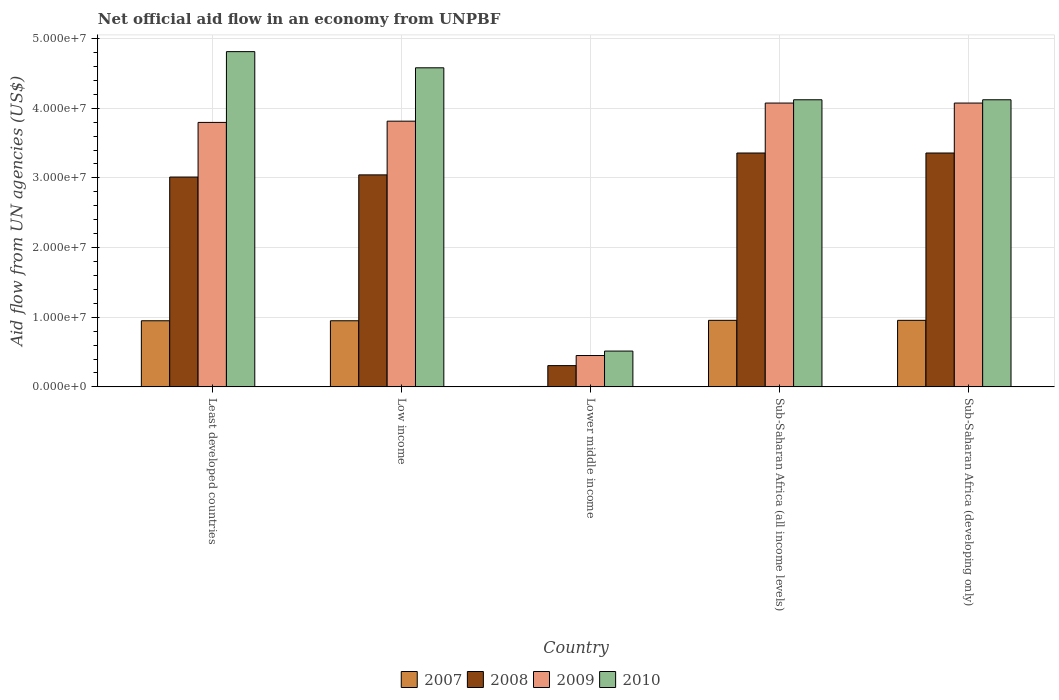How many different coloured bars are there?
Offer a very short reply. 4. How many groups of bars are there?
Your answer should be compact. 5. Are the number of bars per tick equal to the number of legend labels?
Keep it short and to the point. Yes. Are the number of bars on each tick of the X-axis equal?
Give a very brief answer. Yes. How many bars are there on the 5th tick from the left?
Provide a short and direct response. 4. How many bars are there on the 5th tick from the right?
Give a very brief answer. 4. What is the label of the 3rd group of bars from the left?
Provide a short and direct response. Lower middle income. In how many cases, is the number of bars for a given country not equal to the number of legend labels?
Your response must be concise. 0. What is the net official aid flow in 2007 in Sub-Saharan Africa (all income levels)?
Keep it short and to the point. 9.55e+06. Across all countries, what is the maximum net official aid flow in 2010?
Make the answer very short. 4.81e+07. Across all countries, what is the minimum net official aid flow in 2010?
Your response must be concise. 5.14e+06. In which country was the net official aid flow in 2009 maximum?
Keep it short and to the point. Sub-Saharan Africa (all income levels). In which country was the net official aid flow in 2009 minimum?
Your response must be concise. Lower middle income. What is the total net official aid flow in 2009 in the graph?
Your answer should be compact. 1.62e+08. What is the difference between the net official aid flow in 2009 in Low income and that in Sub-Saharan Africa (all income levels)?
Your answer should be compact. -2.60e+06. What is the difference between the net official aid flow in 2010 in Low income and the net official aid flow in 2009 in Sub-Saharan Africa (all income levels)?
Your answer should be very brief. 5.06e+06. What is the average net official aid flow in 2010 per country?
Keep it short and to the point. 3.63e+07. What is the difference between the net official aid flow of/in 2009 and net official aid flow of/in 2008 in Lower middle income?
Make the answer very short. 1.45e+06. In how many countries, is the net official aid flow in 2010 greater than 38000000 US$?
Ensure brevity in your answer.  4. What is the ratio of the net official aid flow in 2010 in Lower middle income to that in Sub-Saharan Africa (all income levels)?
Provide a succinct answer. 0.12. What is the difference between the highest and the second highest net official aid flow in 2010?
Offer a terse response. 2.32e+06. What is the difference between the highest and the lowest net official aid flow in 2008?
Provide a short and direct response. 3.05e+07. In how many countries, is the net official aid flow in 2007 greater than the average net official aid flow in 2007 taken over all countries?
Give a very brief answer. 4. Is the sum of the net official aid flow in 2010 in Least developed countries and Lower middle income greater than the maximum net official aid flow in 2008 across all countries?
Offer a very short reply. Yes. Is it the case that in every country, the sum of the net official aid flow in 2008 and net official aid flow in 2009 is greater than the sum of net official aid flow in 2007 and net official aid flow in 2010?
Make the answer very short. No. What does the 2nd bar from the left in Lower middle income represents?
Offer a very short reply. 2008. How many bars are there?
Your answer should be compact. 20. Are all the bars in the graph horizontal?
Provide a succinct answer. No. How many countries are there in the graph?
Your answer should be very brief. 5. What is the difference between two consecutive major ticks on the Y-axis?
Your answer should be compact. 1.00e+07. Does the graph contain grids?
Provide a short and direct response. Yes. How many legend labels are there?
Give a very brief answer. 4. How are the legend labels stacked?
Ensure brevity in your answer.  Horizontal. What is the title of the graph?
Provide a short and direct response. Net official aid flow in an economy from UNPBF. What is the label or title of the Y-axis?
Give a very brief answer. Aid flow from UN agencies (US$). What is the Aid flow from UN agencies (US$) of 2007 in Least developed countries?
Keep it short and to the point. 9.49e+06. What is the Aid flow from UN agencies (US$) of 2008 in Least developed countries?
Your response must be concise. 3.01e+07. What is the Aid flow from UN agencies (US$) in 2009 in Least developed countries?
Make the answer very short. 3.80e+07. What is the Aid flow from UN agencies (US$) of 2010 in Least developed countries?
Provide a succinct answer. 4.81e+07. What is the Aid flow from UN agencies (US$) of 2007 in Low income?
Make the answer very short. 9.49e+06. What is the Aid flow from UN agencies (US$) in 2008 in Low income?
Provide a short and direct response. 3.04e+07. What is the Aid flow from UN agencies (US$) of 2009 in Low income?
Your answer should be compact. 3.81e+07. What is the Aid flow from UN agencies (US$) in 2010 in Low income?
Provide a succinct answer. 4.58e+07. What is the Aid flow from UN agencies (US$) in 2008 in Lower middle income?
Your response must be concise. 3.05e+06. What is the Aid flow from UN agencies (US$) in 2009 in Lower middle income?
Provide a succinct answer. 4.50e+06. What is the Aid flow from UN agencies (US$) of 2010 in Lower middle income?
Give a very brief answer. 5.14e+06. What is the Aid flow from UN agencies (US$) of 2007 in Sub-Saharan Africa (all income levels)?
Your response must be concise. 9.55e+06. What is the Aid flow from UN agencies (US$) of 2008 in Sub-Saharan Africa (all income levels)?
Give a very brief answer. 3.36e+07. What is the Aid flow from UN agencies (US$) of 2009 in Sub-Saharan Africa (all income levels)?
Offer a very short reply. 4.07e+07. What is the Aid flow from UN agencies (US$) in 2010 in Sub-Saharan Africa (all income levels)?
Provide a succinct answer. 4.12e+07. What is the Aid flow from UN agencies (US$) in 2007 in Sub-Saharan Africa (developing only)?
Your answer should be compact. 9.55e+06. What is the Aid flow from UN agencies (US$) of 2008 in Sub-Saharan Africa (developing only)?
Give a very brief answer. 3.36e+07. What is the Aid flow from UN agencies (US$) of 2009 in Sub-Saharan Africa (developing only)?
Keep it short and to the point. 4.07e+07. What is the Aid flow from UN agencies (US$) in 2010 in Sub-Saharan Africa (developing only)?
Your response must be concise. 4.12e+07. Across all countries, what is the maximum Aid flow from UN agencies (US$) of 2007?
Provide a succinct answer. 9.55e+06. Across all countries, what is the maximum Aid flow from UN agencies (US$) of 2008?
Offer a very short reply. 3.36e+07. Across all countries, what is the maximum Aid flow from UN agencies (US$) in 2009?
Your answer should be compact. 4.07e+07. Across all countries, what is the maximum Aid flow from UN agencies (US$) in 2010?
Offer a terse response. 4.81e+07. Across all countries, what is the minimum Aid flow from UN agencies (US$) in 2007?
Your answer should be compact. 6.00e+04. Across all countries, what is the minimum Aid flow from UN agencies (US$) of 2008?
Offer a terse response. 3.05e+06. Across all countries, what is the minimum Aid flow from UN agencies (US$) in 2009?
Your answer should be very brief. 4.50e+06. Across all countries, what is the minimum Aid flow from UN agencies (US$) in 2010?
Provide a succinct answer. 5.14e+06. What is the total Aid flow from UN agencies (US$) in 2007 in the graph?
Offer a terse response. 3.81e+07. What is the total Aid flow from UN agencies (US$) of 2008 in the graph?
Ensure brevity in your answer.  1.31e+08. What is the total Aid flow from UN agencies (US$) of 2009 in the graph?
Offer a terse response. 1.62e+08. What is the total Aid flow from UN agencies (US$) in 2010 in the graph?
Give a very brief answer. 1.81e+08. What is the difference between the Aid flow from UN agencies (US$) in 2008 in Least developed countries and that in Low income?
Offer a terse response. -3.10e+05. What is the difference between the Aid flow from UN agencies (US$) of 2010 in Least developed countries and that in Low income?
Your answer should be very brief. 2.32e+06. What is the difference between the Aid flow from UN agencies (US$) of 2007 in Least developed countries and that in Lower middle income?
Your answer should be very brief. 9.43e+06. What is the difference between the Aid flow from UN agencies (US$) in 2008 in Least developed countries and that in Lower middle income?
Provide a succinct answer. 2.71e+07. What is the difference between the Aid flow from UN agencies (US$) in 2009 in Least developed countries and that in Lower middle income?
Give a very brief answer. 3.35e+07. What is the difference between the Aid flow from UN agencies (US$) in 2010 in Least developed countries and that in Lower middle income?
Provide a short and direct response. 4.30e+07. What is the difference between the Aid flow from UN agencies (US$) of 2007 in Least developed countries and that in Sub-Saharan Africa (all income levels)?
Your answer should be compact. -6.00e+04. What is the difference between the Aid flow from UN agencies (US$) in 2008 in Least developed countries and that in Sub-Saharan Africa (all income levels)?
Offer a terse response. -3.45e+06. What is the difference between the Aid flow from UN agencies (US$) of 2009 in Least developed countries and that in Sub-Saharan Africa (all income levels)?
Offer a very short reply. -2.78e+06. What is the difference between the Aid flow from UN agencies (US$) of 2010 in Least developed countries and that in Sub-Saharan Africa (all income levels)?
Your answer should be compact. 6.91e+06. What is the difference between the Aid flow from UN agencies (US$) in 2007 in Least developed countries and that in Sub-Saharan Africa (developing only)?
Offer a terse response. -6.00e+04. What is the difference between the Aid flow from UN agencies (US$) in 2008 in Least developed countries and that in Sub-Saharan Africa (developing only)?
Ensure brevity in your answer.  -3.45e+06. What is the difference between the Aid flow from UN agencies (US$) of 2009 in Least developed countries and that in Sub-Saharan Africa (developing only)?
Keep it short and to the point. -2.78e+06. What is the difference between the Aid flow from UN agencies (US$) of 2010 in Least developed countries and that in Sub-Saharan Africa (developing only)?
Your response must be concise. 6.91e+06. What is the difference between the Aid flow from UN agencies (US$) in 2007 in Low income and that in Lower middle income?
Offer a terse response. 9.43e+06. What is the difference between the Aid flow from UN agencies (US$) of 2008 in Low income and that in Lower middle income?
Your response must be concise. 2.74e+07. What is the difference between the Aid flow from UN agencies (US$) in 2009 in Low income and that in Lower middle income?
Keep it short and to the point. 3.36e+07. What is the difference between the Aid flow from UN agencies (US$) in 2010 in Low income and that in Lower middle income?
Offer a very short reply. 4.07e+07. What is the difference between the Aid flow from UN agencies (US$) in 2007 in Low income and that in Sub-Saharan Africa (all income levels)?
Make the answer very short. -6.00e+04. What is the difference between the Aid flow from UN agencies (US$) of 2008 in Low income and that in Sub-Saharan Africa (all income levels)?
Provide a succinct answer. -3.14e+06. What is the difference between the Aid flow from UN agencies (US$) in 2009 in Low income and that in Sub-Saharan Africa (all income levels)?
Provide a short and direct response. -2.60e+06. What is the difference between the Aid flow from UN agencies (US$) in 2010 in Low income and that in Sub-Saharan Africa (all income levels)?
Provide a succinct answer. 4.59e+06. What is the difference between the Aid flow from UN agencies (US$) of 2007 in Low income and that in Sub-Saharan Africa (developing only)?
Your response must be concise. -6.00e+04. What is the difference between the Aid flow from UN agencies (US$) of 2008 in Low income and that in Sub-Saharan Africa (developing only)?
Your answer should be compact. -3.14e+06. What is the difference between the Aid flow from UN agencies (US$) in 2009 in Low income and that in Sub-Saharan Africa (developing only)?
Offer a terse response. -2.60e+06. What is the difference between the Aid flow from UN agencies (US$) of 2010 in Low income and that in Sub-Saharan Africa (developing only)?
Offer a very short reply. 4.59e+06. What is the difference between the Aid flow from UN agencies (US$) in 2007 in Lower middle income and that in Sub-Saharan Africa (all income levels)?
Offer a very short reply. -9.49e+06. What is the difference between the Aid flow from UN agencies (US$) in 2008 in Lower middle income and that in Sub-Saharan Africa (all income levels)?
Offer a very short reply. -3.05e+07. What is the difference between the Aid flow from UN agencies (US$) of 2009 in Lower middle income and that in Sub-Saharan Africa (all income levels)?
Give a very brief answer. -3.62e+07. What is the difference between the Aid flow from UN agencies (US$) of 2010 in Lower middle income and that in Sub-Saharan Africa (all income levels)?
Provide a short and direct response. -3.61e+07. What is the difference between the Aid flow from UN agencies (US$) of 2007 in Lower middle income and that in Sub-Saharan Africa (developing only)?
Offer a terse response. -9.49e+06. What is the difference between the Aid flow from UN agencies (US$) in 2008 in Lower middle income and that in Sub-Saharan Africa (developing only)?
Ensure brevity in your answer.  -3.05e+07. What is the difference between the Aid flow from UN agencies (US$) in 2009 in Lower middle income and that in Sub-Saharan Africa (developing only)?
Provide a short and direct response. -3.62e+07. What is the difference between the Aid flow from UN agencies (US$) of 2010 in Lower middle income and that in Sub-Saharan Africa (developing only)?
Your answer should be very brief. -3.61e+07. What is the difference between the Aid flow from UN agencies (US$) in 2008 in Sub-Saharan Africa (all income levels) and that in Sub-Saharan Africa (developing only)?
Keep it short and to the point. 0. What is the difference between the Aid flow from UN agencies (US$) in 2009 in Sub-Saharan Africa (all income levels) and that in Sub-Saharan Africa (developing only)?
Ensure brevity in your answer.  0. What is the difference between the Aid flow from UN agencies (US$) in 2007 in Least developed countries and the Aid flow from UN agencies (US$) in 2008 in Low income?
Your answer should be compact. -2.09e+07. What is the difference between the Aid flow from UN agencies (US$) in 2007 in Least developed countries and the Aid flow from UN agencies (US$) in 2009 in Low income?
Give a very brief answer. -2.86e+07. What is the difference between the Aid flow from UN agencies (US$) of 2007 in Least developed countries and the Aid flow from UN agencies (US$) of 2010 in Low income?
Make the answer very short. -3.63e+07. What is the difference between the Aid flow from UN agencies (US$) in 2008 in Least developed countries and the Aid flow from UN agencies (US$) in 2009 in Low income?
Your answer should be compact. -8.02e+06. What is the difference between the Aid flow from UN agencies (US$) of 2008 in Least developed countries and the Aid flow from UN agencies (US$) of 2010 in Low income?
Your answer should be compact. -1.57e+07. What is the difference between the Aid flow from UN agencies (US$) in 2009 in Least developed countries and the Aid flow from UN agencies (US$) in 2010 in Low income?
Ensure brevity in your answer.  -7.84e+06. What is the difference between the Aid flow from UN agencies (US$) of 2007 in Least developed countries and the Aid flow from UN agencies (US$) of 2008 in Lower middle income?
Ensure brevity in your answer.  6.44e+06. What is the difference between the Aid flow from UN agencies (US$) in 2007 in Least developed countries and the Aid flow from UN agencies (US$) in 2009 in Lower middle income?
Offer a very short reply. 4.99e+06. What is the difference between the Aid flow from UN agencies (US$) in 2007 in Least developed countries and the Aid flow from UN agencies (US$) in 2010 in Lower middle income?
Your answer should be compact. 4.35e+06. What is the difference between the Aid flow from UN agencies (US$) in 2008 in Least developed countries and the Aid flow from UN agencies (US$) in 2009 in Lower middle income?
Give a very brief answer. 2.56e+07. What is the difference between the Aid flow from UN agencies (US$) of 2008 in Least developed countries and the Aid flow from UN agencies (US$) of 2010 in Lower middle income?
Provide a succinct answer. 2.50e+07. What is the difference between the Aid flow from UN agencies (US$) in 2009 in Least developed countries and the Aid flow from UN agencies (US$) in 2010 in Lower middle income?
Keep it short and to the point. 3.28e+07. What is the difference between the Aid flow from UN agencies (US$) in 2007 in Least developed countries and the Aid flow from UN agencies (US$) in 2008 in Sub-Saharan Africa (all income levels)?
Give a very brief answer. -2.41e+07. What is the difference between the Aid flow from UN agencies (US$) in 2007 in Least developed countries and the Aid flow from UN agencies (US$) in 2009 in Sub-Saharan Africa (all income levels)?
Your response must be concise. -3.12e+07. What is the difference between the Aid flow from UN agencies (US$) of 2007 in Least developed countries and the Aid flow from UN agencies (US$) of 2010 in Sub-Saharan Africa (all income levels)?
Give a very brief answer. -3.17e+07. What is the difference between the Aid flow from UN agencies (US$) of 2008 in Least developed countries and the Aid flow from UN agencies (US$) of 2009 in Sub-Saharan Africa (all income levels)?
Your answer should be compact. -1.06e+07. What is the difference between the Aid flow from UN agencies (US$) of 2008 in Least developed countries and the Aid flow from UN agencies (US$) of 2010 in Sub-Saharan Africa (all income levels)?
Give a very brief answer. -1.11e+07. What is the difference between the Aid flow from UN agencies (US$) of 2009 in Least developed countries and the Aid flow from UN agencies (US$) of 2010 in Sub-Saharan Africa (all income levels)?
Provide a short and direct response. -3.25e+06. What is the difference between the Aid flow from UN agencies (US$) in 2007 in Least developed countries and the Aid flow from UN agencies (US$) in 2008 in Sub-Saharan Africa (developing only)?
Your response must be concise. -2.41e+07. What is the difference between the Aid flow from UN agencies (US$) in 2007 in Least developed countries and the Aid flow from UN agencies (US$) in 2009 in Sub-Saharan Africa (developing only)?
Your answer should be compact. -3.12e+07. What is the difference between the Aid flow from UN agencies (US$) in 2007 in Least developed countries and the Aid flow from UN agencies (US$) in 2010 in Sub-Saharan Africa (developing only)?
Offer a very short reply. -3.17e+07. What is the difference between the Aid flow from UN agencies (US$) of 2008 in Least developed countries and the Aid flow from UN agencies (US$) of 2009 in Sub-Saharan Africa (developing only)?
Provide a short and direct response. -1.06e+07. What is the difference between the Aid flow from UN agencies (US$) in 2008 in Least developed countries and the Aid flow from UN agencies (US$) in 2010 in Sub-Saharan Africa (developing only)?
Ensure brevity in your answer.  -1.11e+07. What is the difference between the Aid flow from UN agencies (US$) in 2009 in Least developed countries and the Aid flow from UN agencies (US$) in 2010 in Sub-Saharan Africa (developing only)?
Offer a very short reply. -3.25e+06. What is the difference between the Aid flow from UN agencies (US$) of 2007 in Low income and the Aid flow from UN agencies (US$) of 2008 in Lower middle income?
Your response must be concise. 6.44e+06. What is the difference between the Aid flow from UN agencies (US$) of 2007 in Low income and the Aid flow from UN agencies (US$) of 2009 in Lower middle income?
Offer a very short reply. 4.99e+06. What is the difference between the Aid flow from UN agencies (US$) in 2007 in Low income and the Aid flow from UN agencies (US$) in 2010 in Lower middle income?
Keep it short and to the point. 4.35e+06. What is the difference between the Aid flow from UN agencies (US$) of 2008 in Low income and the Aid flow from UN agencies (US$) of 2009 in Lower middle income?
Ensure brevity in your answer.  2.59e+07. What is the difference between the Aid flow from UN agencies (US$) of 2008 in Low income and the Aid flow from UN agencies (US$) of 2010 in Lower middle income?
Your answer should be very brief. 2.53e+07. What is the difference between the Aid flow from UN agencies (US$) in 2009 in Low income and the Aid flow from UN agencies (US$) in 2010 in Lower middle income?
Make the answer very short. 3.30e+07. What is the difference between the Aid flow from UN agencies (US$) in 2007 in Low income and the Aid flow from UN agencies (US$) in 2008 in Sub-Saharan Africa (all income levels)?
Your response must be concise. -2.41e+07. What is the difference between the Aid flow from UN agencies (US$) in 2007 in Low income and the Aid flow from UN agencies (US$) in 2009 in Sub-Saharan Africa (all income levels)?
Make the answer very short. -3.12e+07. What is the difference between the Aid flow from UN agencies (US$) in 2007 in Low income and the Aid flow from UN agencies (US$) in 2010 in Sub-Saharan Africa (all income levels)?
Keep it short and to the point. -3.17e+07. What is the difference between the Aid flow from UN agencies (US$) of 2008 in Low income and the Aid flow from UN agencies (US$) of 2009 in Sub-Saharan Africa (all income levels)?
Your answer should be very brief. -1.03e+07. What is the difference between the Aid flow from UN agencies (US$) of 2008 in Low income and the Aid flow from UN agencies (US$) of 2010 in Sub-Saharan Africa (all income levels)?
Keep it short and to the point. -1.08e+07. What is the difference between the Aid flow from UN agencies (US$) of 2009 in Low income and the Aid flow from UN agencies (US$) of 2010 in Sub-Saharan Africa (all income levels)?
Provide a short and direct response. -3.07e+06. What is the difference between the Aid flow from UN agencies (US$) of 2007 in Low income and the Aid flow from UN agencies (US$) of 2008 in Sub-Saharan Africa (developing only)?
Provide a short and direct response. -2.41e+07. What is the difference between the Aid flow from UN agencies (US$) of 2007 in Low income and the Aid flow from UN agencies (US$) of 2009 in Sub-Saharan Africa (developing only)?
Offer a very short reply. -3.12e+07. What is the difference between the Aid flow from UN agencies (US$) in 2007 in Low income and the Aid flow from UN agencies (US$) in 2010 in Sub-Saharan Africa (developing only)?
Provide a short and direct response. -3.17e+07. What is the difference between the Aid flow from UN agencies (US$) in 2008 in Low income and the Aid flow from UN agencies (US$) in 2009 in Sub-Saharan Africa (developing only)?
Keep it short and to the point. -1.03e+07. What is the difference between the Aid flow from UN agencies (US$) of 2008 in Low income and the Aid flow from UN agencies (US$) of 2010 in Sub-Saharan Africa (developing only)?
Your answer should be compact. -1.08e+07. What is the difference between the Aid flow from UN agencies (US$) of 2009 in Low income and the Aid flow from UN agencies (US$) of 2010 in Sub-Saharan Africa (developing only)?
Provide a short and direct response. -3.07e+06. What is the difference between the Aid flow from UN agencies (US$) in 2007 in Lower middle income and the Aid flow from UN agencies (US$) in 2008 in Sub-Saharan Africa (all income levels)?
Your answer should be compact. -3.35e+07. What is the difference between the Aid flow from UN agencies (US$) in 2007 in Lower middle income and the Aid flow from UN agencies (US$) in 2009 in Sub-Saharan Africa (all income levels)?
Your response must be concise. -4.07e+07. What is the difference between the Aid flow from UN agencies (US$) of 2007 in Lower middle income and the Aid flow from UN agencies (US$) of 2010 in Sub-Saharan Africa (all income levels)?
Offer a terse response. -4.12e+07. What is the difference between the Aid flow from UN agencies (US$) in 2008 in Lower middle income and the Aid flow from UN agencies (US$) in 2009 in Sub-Saharan Africa (all income levels)?
Provide a succinct answer. -3.77e+07. What is the difference between the Aid flow from UN agencies (US$) of 2008 in Lower middle income and the Aid flow from UN agencies (US$) of 2010 in Sub-Saharan Africa (all income levels)?
Make the answer very short. -3.82e+07. What is the difference between the Aid flow from UN agencies (US$) of 2009 in Lower middle income and the Aid flow from UN agencies (US$) of 2010 in Sub-Saharan Africa (all income levels)?
Provide a short and direct response. -3.67e+07. What is the difference between the Aid flow from UN agencies (US$) in 2007 in Lower middle income and the Aid flow from UN agencies (US$) in 2008 in Sub-Saharan Africa (developing only)?
Offer a terse response. -3.35e+07. What is the difference between the Aid flow from UN agencies (US$) in 2007 in Lower middle income and the Aid flow from UN agencies (US$) in 2009 in Sub-Saharan Africa (developing only)?
Offer a very short reply. -4.07e+07. What is the difference between the Aid flow from UN agencies (US$) in 2007 in Lower middle income and the Aid flow from UN agencies (US$) in 2010 in Sub-Saharan Africa (developing only)?
Provide a succinct answer. -4.12e+07. What is the difference between the Aid flow from UN agencies (US$) in 2008 in Lower middle income and the Aid flow from UN agencies (US$) in 2009 in Sub-Saharan Africa (developing only)?
Your response must be concise. -3.77e+07. What is the difference between the Aid flow from UN agencies (US$) of 2008 in Lower middle income and the Aid flow from UN agencies (US$) of 2010 in Sub-Saharan Africa (developing only)?
Your answer should be very brief. -3.82e+07. What is the difference between the Aid flow from UN agencies (US$) in 2009 in Lower middle income and the Aid flow from UN agencies (US$) in 2010 in Sub-Saharan Africa (developing only)?
Provide a short and direct response. -3.67e+07. What is the difference between the Aid flow from UN agencies (US$) in 2007 in Sub-Saharan Africa (all income levels) and the Aid flow from UN agencies (US$) in 2008 in Sub-Saharan Africa (developing only)?
Keep it short and to the point. -2.40e+07. What is the difference between the Aid flow from UN agencies (US$) of 2007 in Sub-Saharan Africa (all income levels) and the Aid flow from UN agencies (US$) of 2009 in Sub-Saharan Africa (developing only)?
Give a very brief answer. -3.12e+07. What is the difference between the Aid flow from UN agencies (US$) in 2007 in Sub-Saharan Africa (all income levels) and the Aid flow from UN agencies (US$) in 2010 in Sub-Saharan Africa (developing only)?
Offer a terse response. -3.17e+07. What is the difference between the Aid flow from UN agencies (US$) of 2008 in Sub-Saharan Africa (all income levels) and the Aid flow from UN agencies (US$) of 2009 in Sub-Saharan Africa (developing only)?
Offer a very short reply. -7.17e+06. What is the difference between the Aid flow from UN agencies (US$) in 2008 in Sub-Saharan Africa (all income levels) and the Aid flow from UN agencies (US$) in 2010 in Sub-Saharan Africa (developing only)?
Ensure brevity in your answer.  -7.64e+06. What is the difference between the Aid flow from UN agencies (US$) of 2009 in Sub-Saharan Africa (all income levels) and the Aid flow from UN agencies (US$) of 2010 in Sub-Saharan Africa (developing only)?
Give a very brief answer. -4.70e+05. What is the average Aid flow from UN agencies (US$) in 2007 per country?
Give a very brief answer. 7.63e+06. What is the average Aid flow from UN agencies (US$) of 2008 per country?
Provide a succinct answer. 2.61e+07. What is the average Aid flow from UN agencies (US$) in 2009 per country?
Provide a short and direct response. 3.24e+07. What is the average Aid flow from UN agencies (US$) of 2010 per country?
Ensure brevity in your answer.  3.63e+07. What is the difference between the Aid flow from UN agencies (US$) of 2007 and Aid flow from UN agencies (US$) of 2008 in Least developed countries?
Your response must be concise. -2.06e+07. What is the difference between the Aid flow from UN agencies (US$) of 2007 and Aid flow from UN agencies (US$) of 2009 in Least developed countries?
Give a very brief answer. -2.85e+07. What is the difference between the Aid flow from UN agencies (US$) in 2007 and Aid flow from UN agencies (US$) in 2010 in Least developed countries?
Provide a succinct answer. -3.86e+07. What is the difference between the Aid flow from UN agencies (US$) of 2008 and Aid flow from UN agencies (US$) of 2009 in Least developed countries?
Keep it short and to the point. -7.84e+06. What is the difference between the Aid flow from UN agencies (US$) in 2008 and Aid flow from UN agencies (US$) in 2010 in Least developed countries?
Provide a short and direct response. -1.80e+07. What is the difference between the Aid flow from UN agencies (US$) in 2009 and Aid flow from UN agencies (US$) in 2010 in Least developed countries?
Offer a very short reply. -1.02e+07. What is the difference between the Aid flow from UN agencies (US$) of 2007 and Aid flow from UN agencies (US$) of 2008 in Low income?
Keep it short and to the point. -2.09e+07. What is the difference between the Aid flow from UN agencies (US$) of 2007 and Aid flow from UN agencies (US$) of 2009 in Low income?
Offer a terse response. -2.86e+07. What is the difference between the Aid flow from UN agencies (US$) of 2007 and Aid flow from UN agencies (US$) of 2010 in Low income?
Keep it short and to the point. -3.63e+07. What is the difference between the Aid flow from UN agencies (US$) of 2008 and Aid flow from UN agencies (US$) of 2009 in Low income?
Your response must be concise. -7.71e+06. What is the difference between the Aid flow from UN agencies (US$) of 2008 and Aid flow from UN agencies (US$) of 2010 in Low income?
Provide a succinct answer. -1.54e+07. What is the difference between the Aid flow from UN agencies (US$) in 2009 and Aid flow from UN agencies (US$) in 2010 in Low income?
Offer a very short reply. -7.66e+06. What is the difference between the Aid flow from UN agencies (US$) in 2007 and Aid flow from UN agencies (US$) in 2008 in Lower middle income?
Provide a short and direct response. -2.99e+06. What is the difference between the Aid flow from UN agencies (US$) of 2007 and Aid flow from UN agencies (US$) of 2009 in Lower middle income?
Your response must be concise. -4.44e+06. What is the difference between the Aid flow from UN agencies (US$) in 2007 and Aid flow from UN agencies (US$) in 2010 in Lower middle income?
Make the answer very short. -5.08e+06. What is the difference between the Aid flow from UN agencies (US$) in 2008 and Aid flow from UN agencies (US$) in 2009 in Lower middle income?
Keep it short and to the point. -1.45e+06. What is the difference between the Aid flow from UN agencies (US$) of 2008 and Aid flow from UN agencies (US$) of 2010 in Lower middle income?
Your answer should be very brief. -2.09e+06. What is the difference between the Aid flow from UN agencies (US$) of 2009 and Aid flow from UN agencies (US$) of 2010 in Lower middle income?
Offer a very short reply. -6.40e+05. What is the difference between the Aid flow from UN agencies (US$) of 2007 and Aid flow from UN agencies (US$) of 2008 in Sub-Saharan Africa (all income levels)?
Offer a terse response. -2.40e+07. What is the difference between the Aid flow from UN agencies (US$) of 2007 and Aid flow from UN agencies (US$) of 2009 in Sub-Saharan Africa (all income levels)?
Your answer should be very brief. -3.12e+07. What is the difference between the Aid flow from UN agencies (US$) in 2007 and Aid flow from UN agencies (US$) in 2010 in Sub-Saharan Africa (all income levels)?
Your answer should be very brief. -3.17e+07. What is the difference between the Aid flow from UN agencies (US$) of 2008 and Aid flow from UN agencies (US$) of 2009 in Sub-Saharan Africa (all income levels)?
Your answer should be very brief. -7.17e+06. What is the difference between the Aid flow from UN agencies (US$) of 2008 and Aid flow from UN agencies (US$) of 2010 in Sub-Saharan Africa (all income levels)?
Make the answer very short. -7.64e+06. What is the difference between the Aid flow from UN agencies (US$) of 2009 and Aid flow from UN agencies (US$) of 2010 in Sub-Saharan Africa (all income levels)?
Your response must be concise. -4.70e+05. What is the difference between the Aid flow from UN agencies (US$) of 2007 and Aid flow from UN agencies (US$) of 2008 in Sub-Saharan Africa (developing only)?
Provide a succinct answer. -2.40e+07. What is the difference between the Aid flow from UN agencies (US$) in 2007 and Aid flow from UN agencies (US$) in 2009 in Sub-Saharan Africa (developing only)?
Make the answer very short. -3.12e+07. What is the difference between the Aid flow from UN agencies (US$) in 2007 and Aid flow from UN agencies (US$) in 2010 in Sub-Saharan Africa (developing only)?
Offer a terse response. -3.17e+07. What is the difference between the Aid flow from UN agencies (US$) in 2008 and Aid flow from UN agencies (US$) in 2009 in Sub-Saharan Africa (developing only)?
Your response must be concise. -7.17e+06. What is the difference between the Aid flow from UN agencies (US$) of 2008 and Aid flow from UN agencies (US$) of 2010 in Sub-Saharan Africa (developing only)?
Your response must be concise. -7.64e+06. What is the difference between the Aid flow from UN agencies (US$) of 2009 and Aid flow from UN agencies (US$) of 2010 in Sub-Saharan Africa (developing only)?
Keep it short and to the point. -4.70e+05. What is the ratio of the Aid flow from UN agencies (US$) in 2007 in Least developed countries to that in Low income?
Provide a succinct answer. 1. What is the ratio of the Aid flow from UN agencies (US$) of 2008 in Least developed countries to that in Low income?
Offer a very short reply. 0.99. What is the ratio of the Aid flow from UN agencies (US$) of 2009 in Least developed countries to that in Low income?
Make the answer very short. 1. What is the ratio of the Aid flow from UN agencies (US$) of 2010 in Least developed countries to that in Low income?
Make the answer very short. 1.05. What is the ratio of the Aid flow from UN agencies (US$) of 2007 in Least developed countries to that in Lower middle income?
Offer a terse response. 158.17. What is the ratio of the Aid flow from UN agencies (US$) in 2008 in Least developed countries to that in Lower middle income?
Make the answer very short. 9.88. What is the ratio of the Aid flow from UN agencies (US$) of 2009 in Least developed countries to that in Lower middle income?
Offer a terse response. 8.44. What is the ratio of the Aid flow from UN agencies (US$) of 2010 in Least developed countries to that in Lower middle income?
Keep it short and to the point. 9.36. What is the ratio of the Aid flow from UN agencies (US$) of 2007 in Least developed countries to that in Sub-Saharan Africa (all income levels)?
Offer a very short reply. 0.99. What is the ratio of the Aid flow from UN agencies (US$) of 2008 in Least developed countries to that in Sub-Saharan Africa (all income levels)?
Your response must be concise. 0.9. What is the ratio of the Aid flow from UN agencies (US$) in 2009 in Least developed countries to that in Sub-Saharan Africa (all income levels)?
Your answer should be compact. 0.93. What is the ratio of the Aid flow from UN agencies (US$) of 2010 in Least developed countries to that in Sub-Saharan Africa (all income levels)?
Make the answer very short. 1.17. What is the ratio of the Aid flow from UN agencies (US$) of 2008 in Least developed countries to that in Sub-Saharan Africa (developing only)?
Offer a very short reply. 0.9. What is the ratio of the Aid flow from UN agencies (US$) of 2009 in Least developed countries to that in Sub-Saharan Africa (developing only)?
Ensure brevity in your answer.  0.93. What is the ratio of the Aid flow from UN agencies (US$) of 2010 in Least developed countries to that in Sub-Saharan Africa (developing only)?
Offer a very short reply. 1.17. What is the ratio of the Aid flow from UN agencies (US$) of 2007 in Low income to that in Lower middle income?
Give a very brief answer. 158.17. What is the ratio of the Aid flow from UN agencies (US$) of 2008 in Low income to that in Lower middle income?
Give a very brief answer. 9.98. What is the ratio of the Aid flow from UN agencies (US$) of 2009 in Low income to that in Lower middle income?
Give a very brief answer. 8.48. What is the ratio of the Aid flow from UN agencies (US$) in 2010 in Low income to that in Lower middle income?
Keep it short and to the point. 8.91. What is the ratio of the Aid flow from UN agencies (US$) of 2008 in Low income to that in Sub-Saharan Africa (all income levels)?
Make the answer very short. 0.91. What is the ratio of the Aid flow from UN agencies (US$) of 2009 in Low income to that in Sub-Saharan Africa (all income levels)?
Your answer should be very brief. 0.94. What is the ratio of the Aid flow from UN agencies (US$) in 2010 in Low income to that in Sub-Saharan Africa (all income levels)?
Make the answer very short. 1.11. What is the ratio of the Aid flow from UN agencies (US$) in 2008 in Low income to that in Sub-Saharan Africa (developing only)?
Your answer should be compact. 0.91. What is the ratio of the Aid flow from UN agencies (US$) in 2009 in Low income to that in Sub-Saharan Africa (developing only)?
Offer a terse response. 0.94. What is the ratio of the Aid flow from UN agencies (US$) in 2010 in Low income to that in Sub-Saharan Africa (developing only)?
Provide a short and direct response. 1.11. What is the ratio of the Aid flow from UN agencies (US$) of 2007 in Lower middle income to that in Sub-Saharan Africa (all income levels)?
Your answer should be compact. 0.01. What is the ratio of the Aid flow from UN agencies (US$) of 2008 in Lower middle income to that in Sub-Saharan Africa (all income levels)?
Your response must be concise. 0.09. What is the ratio of the Aid flow from UN agencies (US$) of 2009 in Lower middle income to that in Sub-Saharan Africa (all income levels)?
Offer a terse response. 0.11. What is the ratio of the Aid flow from UN agencies (US$) in 2010 in Lower middle income to that in Sub-Saharan Africa (all income levels)?
Provide a short and direct response. 0.12. What is the ratio of the Aid flow from UN agencies (US$) of 2007 in Lower middle income to that in Sub-Saharan Africa (developing only)?
Your answer should be compact. 0.01. What is the ratio of the Aid flow from UN agencies (US$) of 2008 in Lower middle income to that in Sub-Saharan Africa (developing only)?
Your answer should be compact. 0.09. What is the ratio of the Aid flow from UN agencies (US$) of 2009 in Lower middle income to that in Sub-Saharan Africa (developing only)?
Offer a terse response. 0.11. What is the ratio of the Aid flow from UN agencies (US$) of 2010 in Lower middle income to that in Sub-Saharan Africa (developing only)?
Ensure brevity in your answer.  0.12. What is the ratio of the Aid flow from UN agencies (US$) of 2007 in Sub-Saharan Africa (all income levels) to that in Sub-Saharan Africa (developing only)?
Offer a very short reply. 1. What is the ratio of the Aid flow from UN agencies (US$) of 2008 in Sub-Saharan Africa (all income levels) to that in Sub-Saharan Africa (developing only)?
Offer a very short reply. 1. What is the difference between the highest and the second highest Aid flow from UN agencies (US$) of 2007?
Give a very brief answer. 0. What is the difference between the highest and the second highest Aid flow from UN agencies (US$) of 2008?
Offer a very short reply. 0. What is the difference between the highest and the second highest Aid flow from UN agencies (US$) in 2010?
Offer a very short reply. 2.32e+06. What is the difference between the highest and the lowest Aid flow from UN agencies (US$) of 2007?
Provide a short and direct response. 9.49e+06. What is the difference between the highest and the lowest Aid flow from UN agencies (US$) of 2008?
Provide a succinct answer. 3.05e+07. What is the difference between the highest and the lowest Aid flow from UN agencies (US$) in 2009?
Your answer should be very brief. 3.62e+07. What is the difference between the highest and the lowest Aid flow from UN agencies (US$) in 2010?
Offer a very short reply. 4.30e+07. 